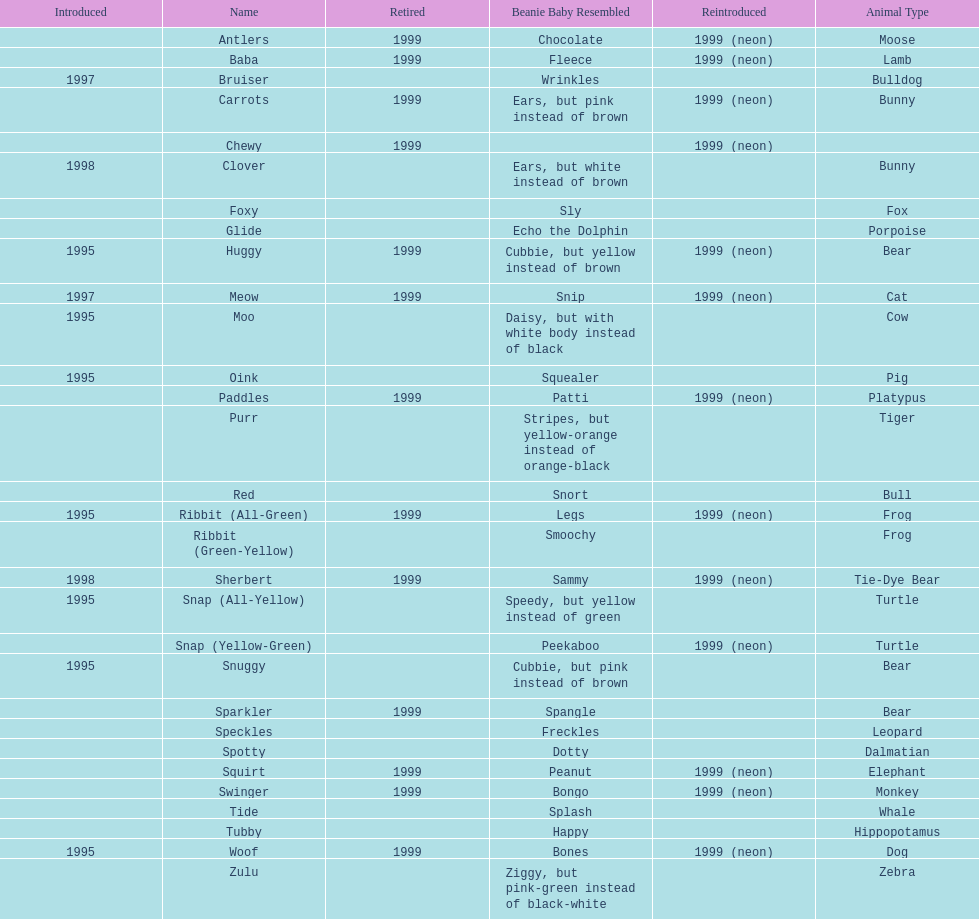How long was woof the dog sold before it was retired? 4 years. 